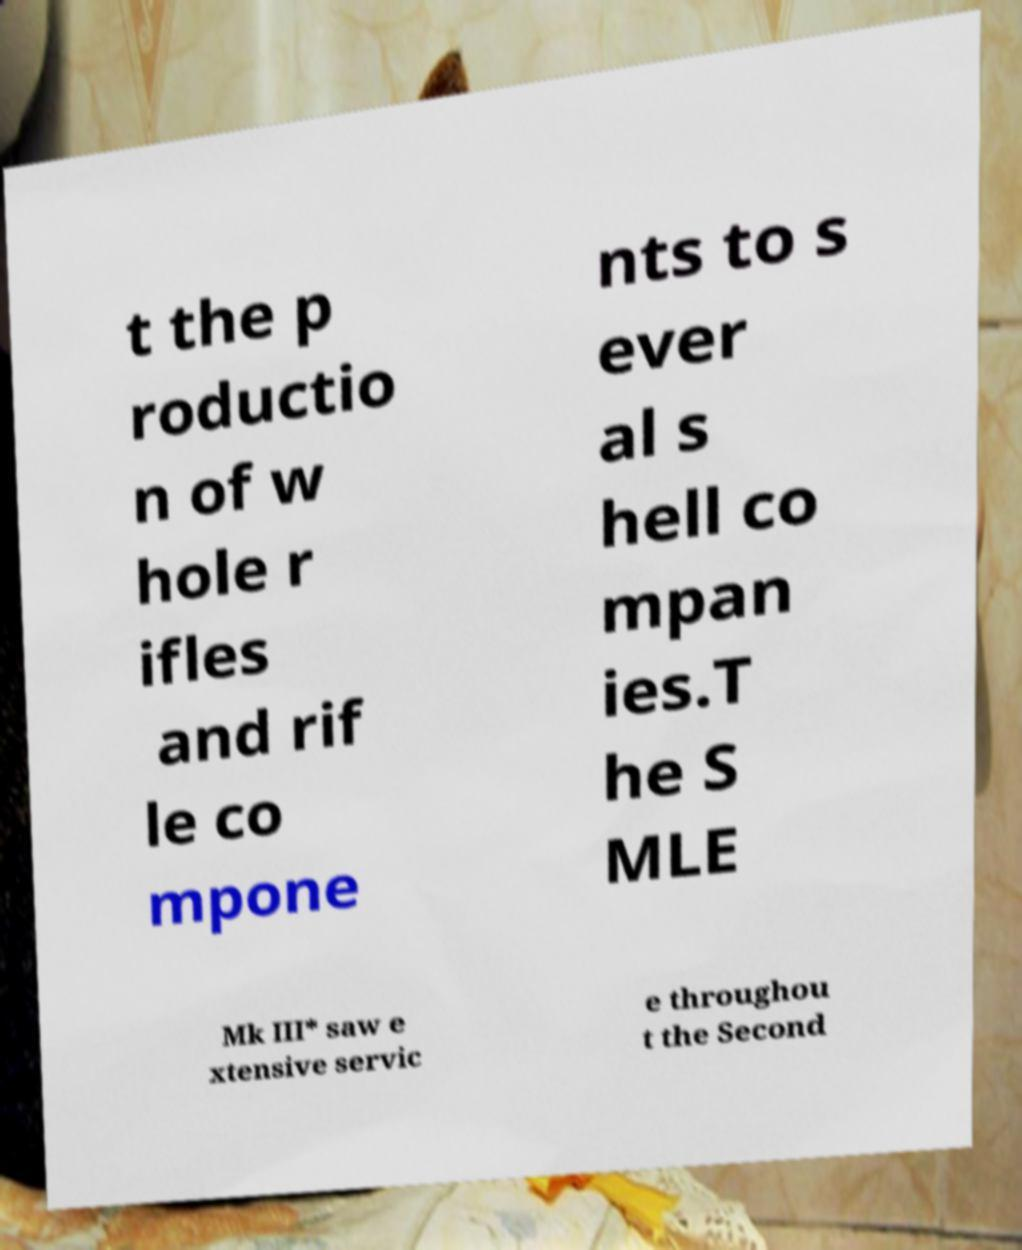What messages or text are displayed in this image? I need them in a readable, typed format. t the p roductio n of w hole r ifles and rif le co mpone nts to s ever al s hell co mpan ies.T he S MLE Mk III* saw e xtensive servic e throughou t the Second 